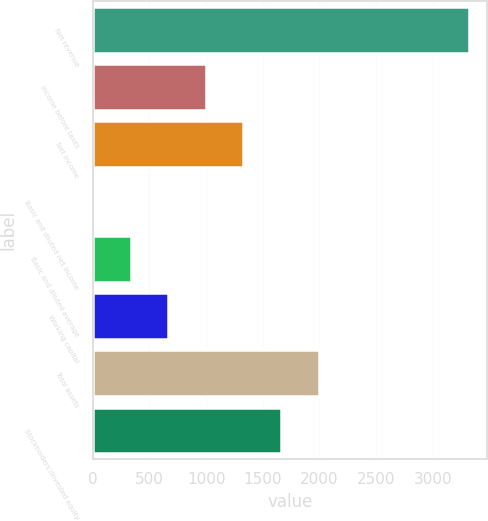Convert chart to OTSL. <chart><loc_0><loc_0><loc_500><loc_500><bar_chart><fcel>Net revenue<fcel>Income before taxes<fcel>Net income<fcel>Basic and diluted net income<fcel>Basic and diluted average<fcel>Working capital<fcel>Total assets<fcel>Stockholders'/Invested equity<nl><fcel>3316<fcel>998.1<fcel>1329.23<fcel>4.71<fcel>335.84<fcel>666.97<fcel>1991.49<fcel>1660.36<nl></chart> 